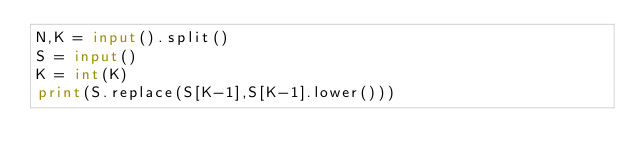Convert code to text. <code><loc_0><loc_0><loc_500><loc_500><_Python_>N,K = input().split()
S = input()
K = int(K)
print(S.replace(S[K-1],S[K-1].lower()))</code> 